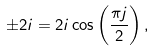<formula> <loc_0><loc_0><loc_500><loc_500>\pm 2 i = 2 i \cos \left ( \frac { \pi j } { 2 } \right ) ,</formula> 